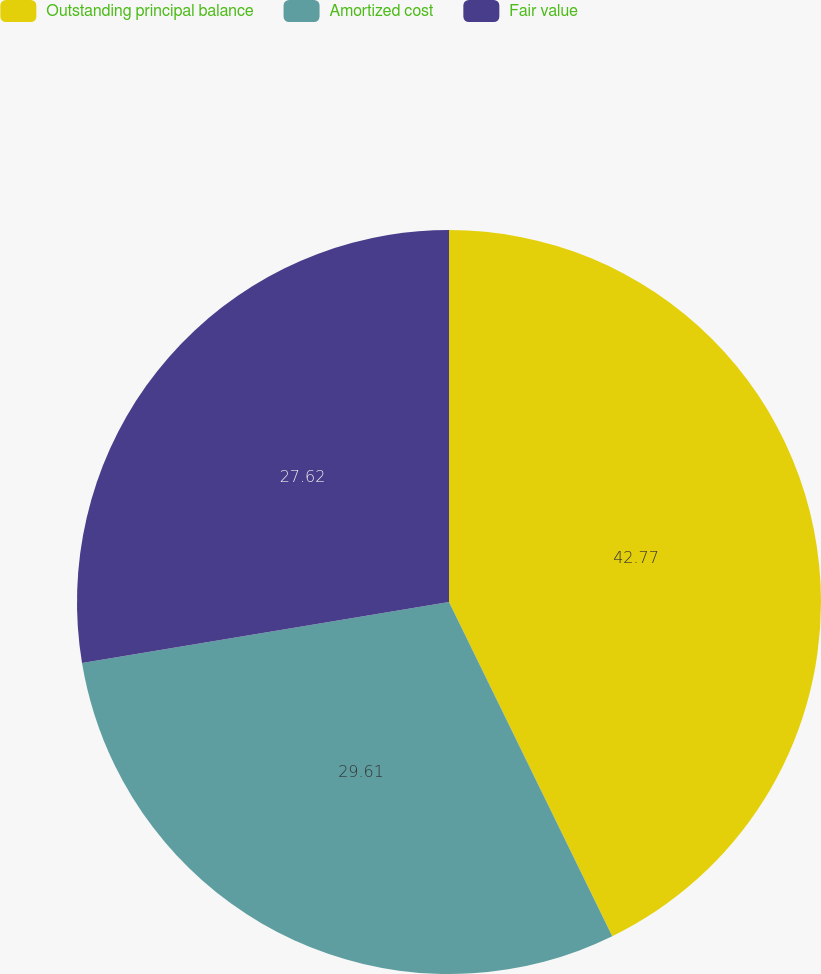Convert chart. <chart><loc_0><loc_0><loc_500><loc_500><pie_chart><fcel>Outstanding principal balance<fcel>Amortized cost<fcel>Fair value<nl><fcel>42.77%<fcel>29.61%<fcel>27.62%<nl></chart> 